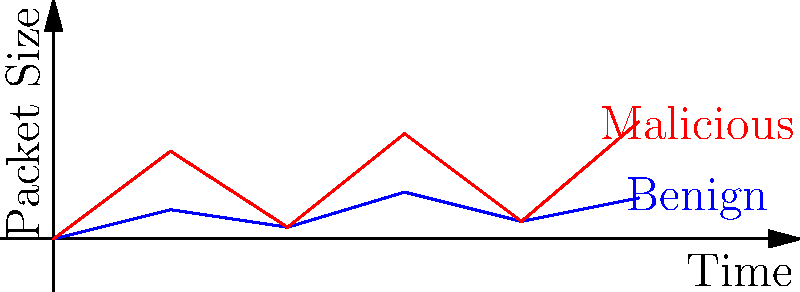As a startup founder concerned with serverless application security, you're analyzing network traffic patterns. The graph shows two types of packet visualizations over time. Which characteristic best distinguishes the malicious traffic from benign traffic in this visualization? To answer this question, let's analyze the graph step-by-step:

1. The graph shows two lines: blue (labeled "Benign") and red (labeled "Malicious").

2. Both lines represent packet sizes over time.

3. Examining the blue line (benign traffic):
   - It shows relatively small fluctuations in packet size.
   - The line stays within a narrow range (approximately 0-10 units).

4. Looking at the red line (malicious traffic):
   - It exhibits larger fluctuations in packet size.
   - The line has higher peaks, reaching up to about 20 units.

5. The key difference between the two lines is the amplitude of fluctuations:
   - Benign traffic has smaller, more consistent packet sizes.
   - Malicious traffic shows larger, more erratic changes in packet sizes.

6. In network security, sudden large spikes in packet size can indicate:
   - Data exfiltration attempts
   - Denial of Service (DoS) attacks
   - Other malicious activities

Therefore, the characteristic that best distinguishes malicious traffic from benign traffic in this visualization is the larger amplitude of fluctuations in packet size over time.
Answer: Larger amplitude of fluctuations in packet size 